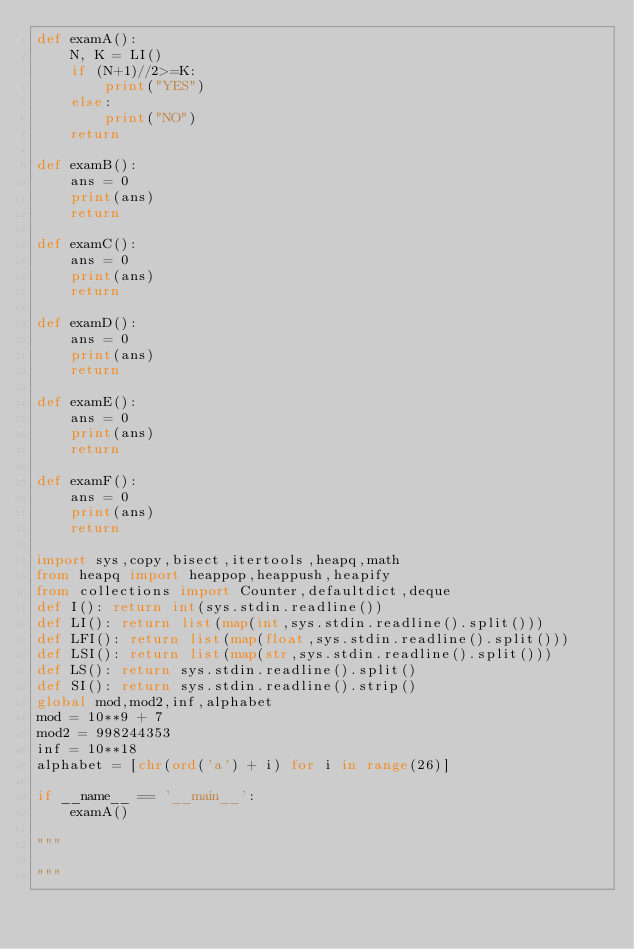<code> <loc_0><loc_0><loc_500><loc_500><_Python_>def examA():
    N, K = LI()
    if (N+1)//2>=K:
        print("YES")
    else:
        print("NO")
    return

def examB():
    ans = 0
    print(ans)
    return

def examC():
    ans = 0
    print(ans)
    return

def examD():
    ans = 0
    print(ans)
    return

def examE():
    ans = 0
    print(ans)
    return

def examF():
    ans = 0
    print(ans)
    return

import sys,copy,bisect,itertools,heapq,math
from heapq import heappop,heappush,heapify
from collections import Counter,defaultdict,deque
def I(): return int(sys.stdin.readline())
def LI(): return list(map(int,sys.stdin.readline().split()))
def LFI(): return list(map(float,sys.stdin.readline().split()))
def LSI(): return list(map(str,sys.stdin.readline().split()))
def LS(): return sys.stdin.readline().split()
def SI(): return sys.stdin.readline().strip()
global mod,mod2,inf,alphabet
mod = 10**9 + 7
mod2 = 998244353
inf = 10**18
alphabet = [chr(ord('a') + i) for i in range(26)]

if __name__ == '__main__':
    examA()

"""

"""</code> 